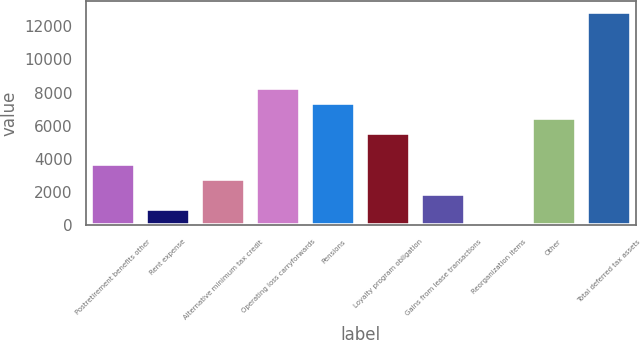Convert chart. <chart><loc_0><loc_0><loc_500><loc_500><bar_chart><fcel>Postretirement benefits other<fcel>Rent expense<fcel>Alternative minimum tax credit<fcel>Operating loss carryforwards<fcel>Pensions<fcel>Loyalty program obligation<fcel>Gains from lease transactions<fcel>Reorganization items<fcel>Other<fcel>Total deferred tax assets<nl><fcel>3720.4<fcel>978.1<fcel>2806.3<fcel>8290.9<fcel>7376.8<fcel>5548.6<fcel>1892.2<fcel>64<fcel>6462.7<fcel>12861.4<nl></chart> 